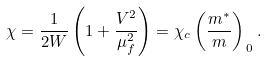Convert formula to latex. <formula><loc_0><loc_0><loc_500><loc_500>\chi = \frac { 1 } { 2 W } \left ( 1 + \frac { V ^ { 2 } } { \mu _ { f } ^ { 2 } } \right ) = \chi _ { c } \left ( \frac { m ^ { * } } { m } \right ) _ { \, 0 } .</formula> 